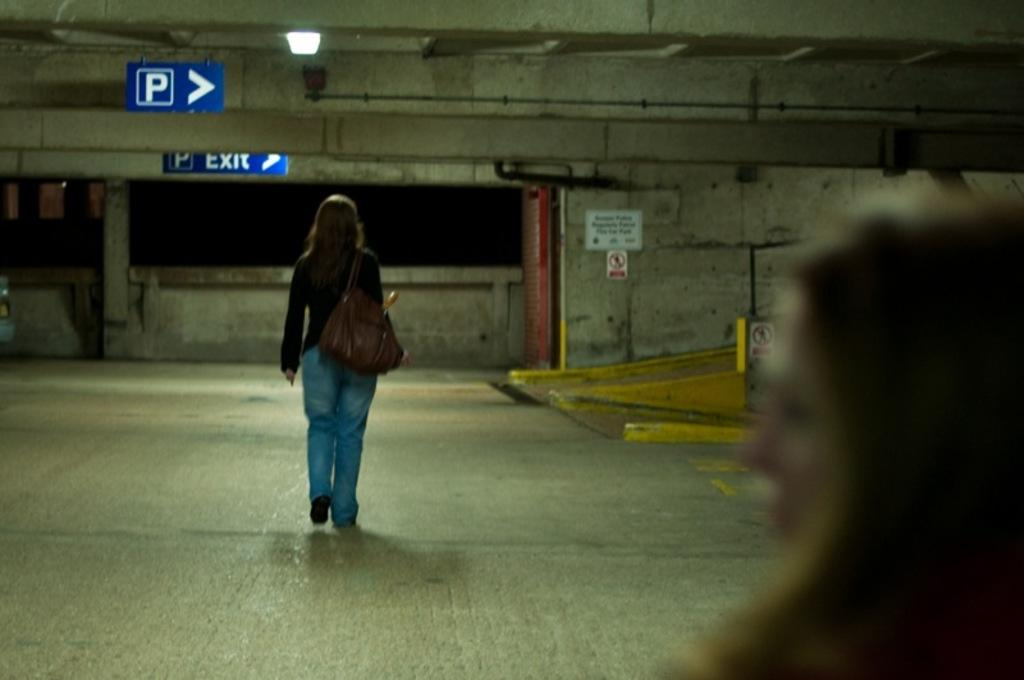What is the woman in the image doing? There is a woman walking in the image. What is the woman carrying? The woman is carrying a bag. Can you describe the other woman in the image? There is another woman in the image, but no specific details are provided. What type of signs can be seen in the image? There are sign boards visible in the image. Where is the light located in the image? There is a light on the roof in the image. How many clocks are visible on the woman's wrist in the image? There are no clocks visible on the woman's wrist in the image. Can you provide an example of a similar scene from a different image? The provided facts only describe the current image, so it is not possible to provide an example from a different image. 